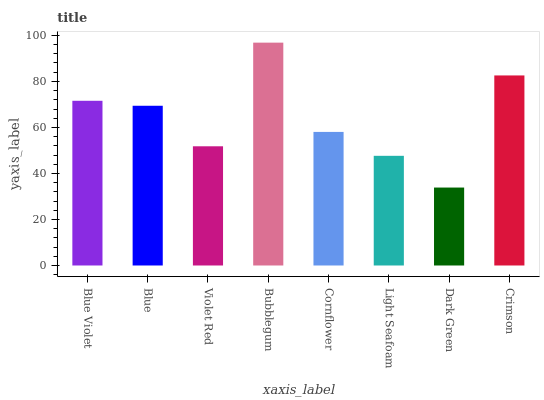Is Dark Green the minimum?
Answer yes or no. Yes. Is Bubblegum the maximum?
Answer yes or no. Yes. Is Blue the minimum?
Answer yes or no. No. Is Blue the maximum?
Answer yes or no. No. Is Blue Violet greater than Blue?
Answer yes or no. Yes. Is Blue less than Blue Violet?
Answer yes or no. Yes. Is Blue greater than Blue Violet?
Answer yes or no. No. Is Blue Violet less than Blue?
Answer yes or no. No. Is Blue the high median?
Answer yes or no. Yes. Is Cornflower the low median?
Answer yes or no. Yes. Is Dark Green the high median?
Answer yes or no. No. Is Violet Red the low median?
Answer yes or no. No. 